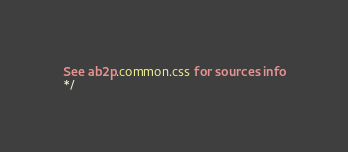Convert code to text. <code><loc_0><loc_0><loc_500><loc_500><_CSS_>See ab2p.common.css for sources info
*/</code> 